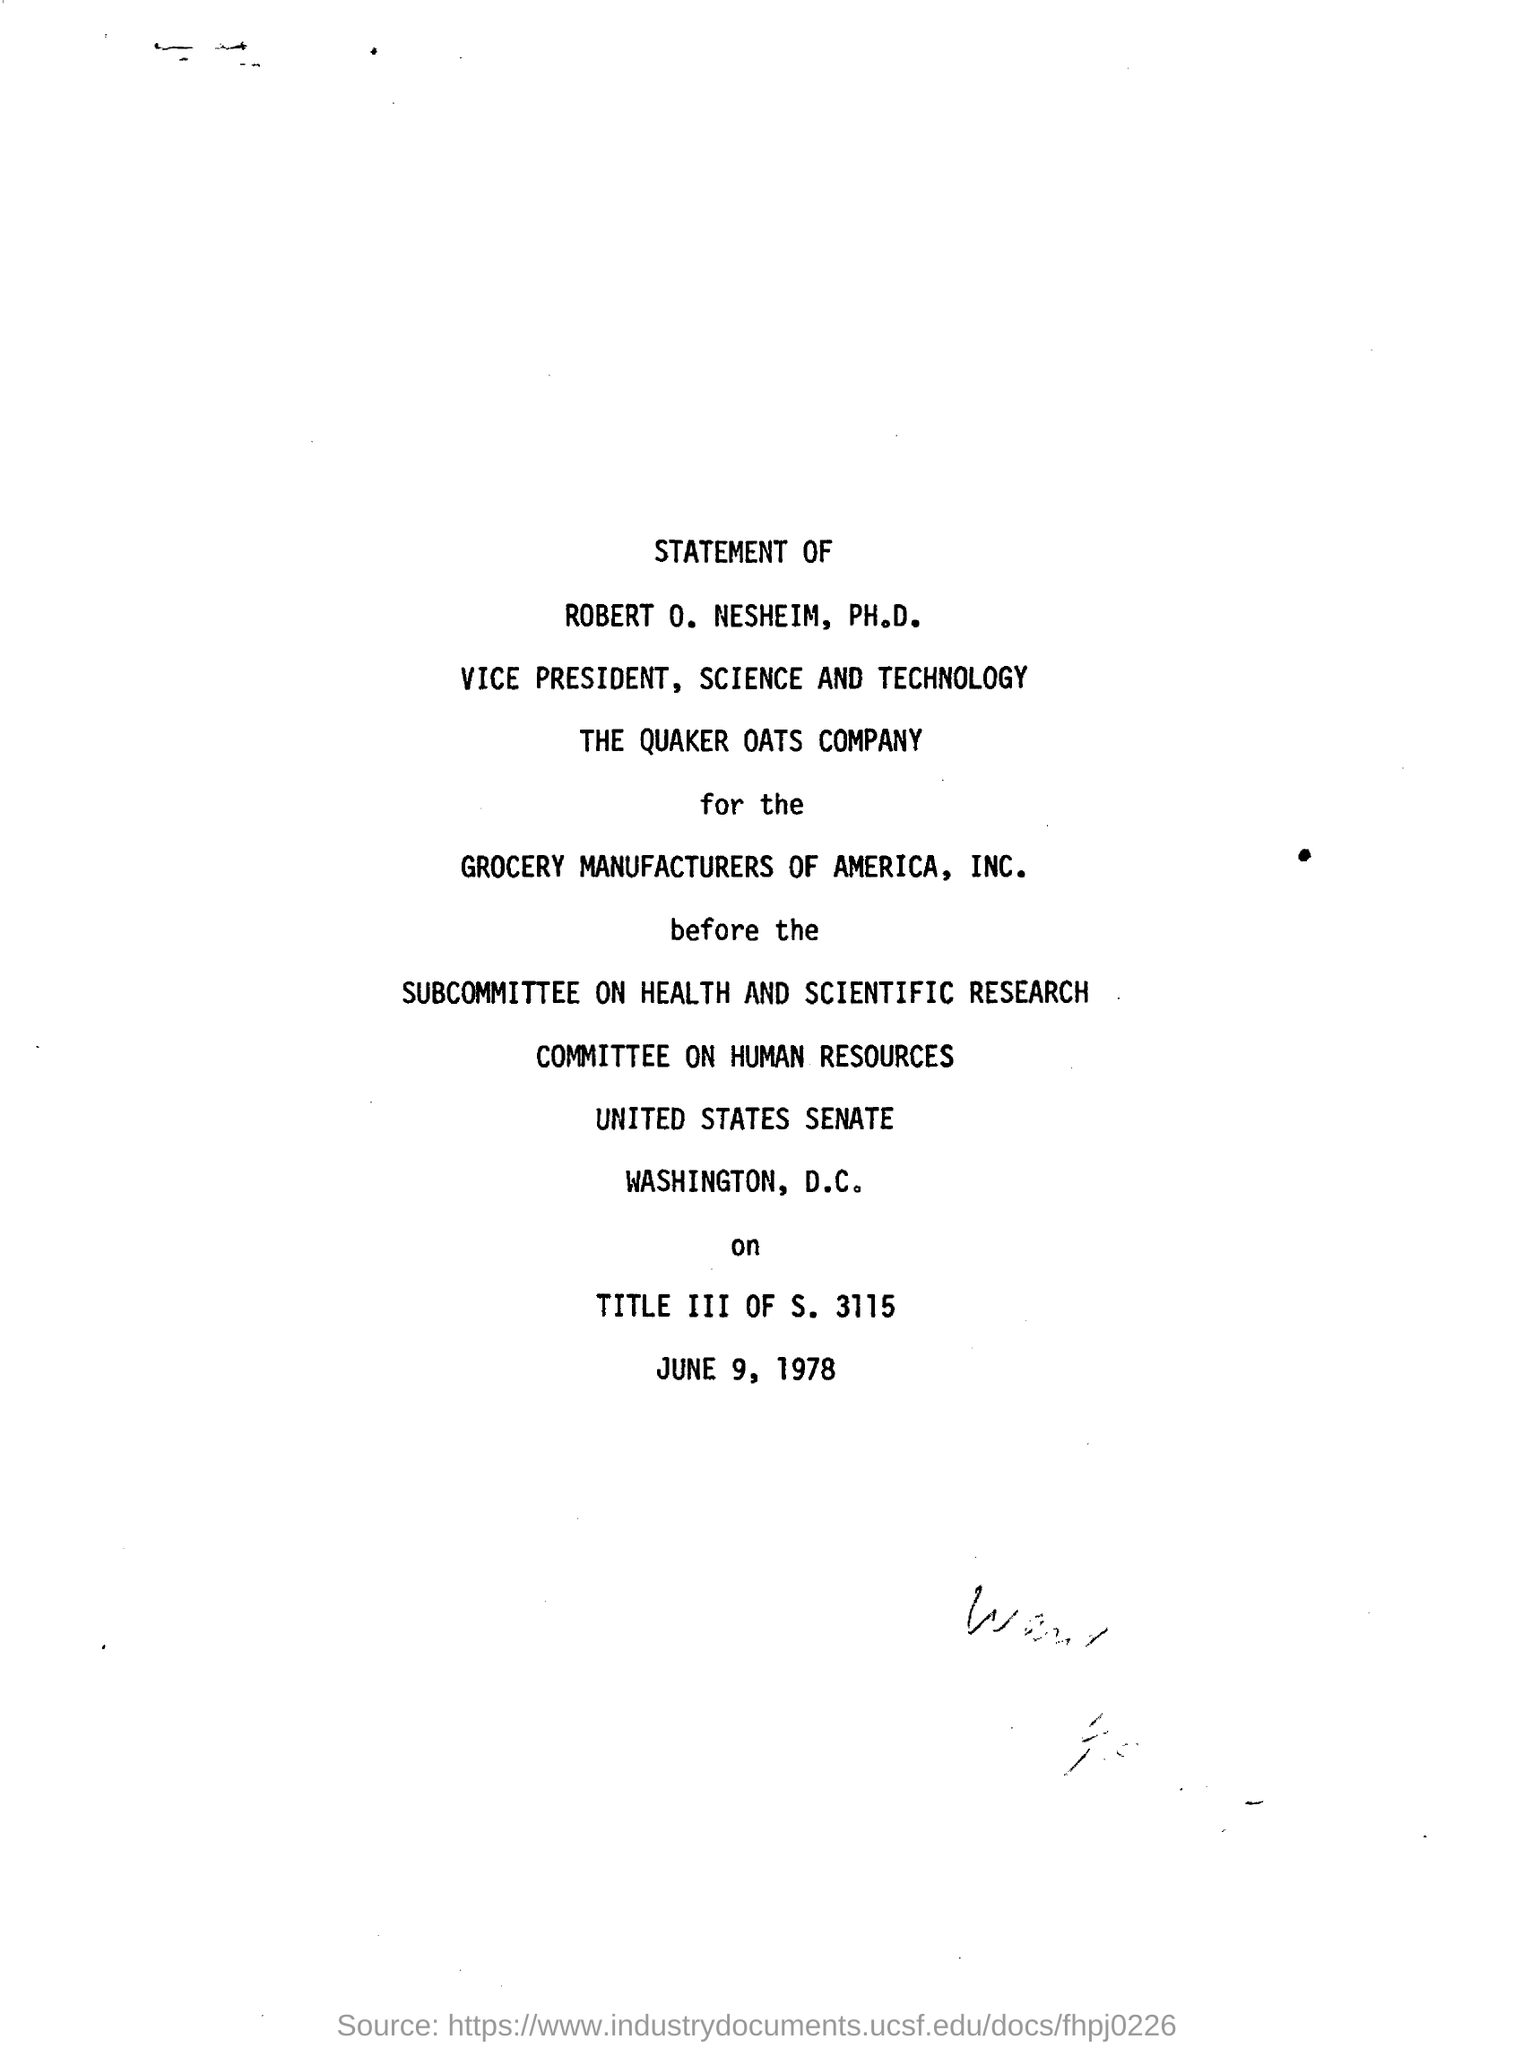Indicate a few pertinent items in this graphic. Robert O. Nesheim, Ph.D., is the vice president of the Quaker Oats Company. The subcommittee was on health and scientific research. The document contains the date of JUNE 9, 1978. 